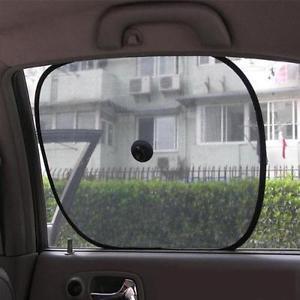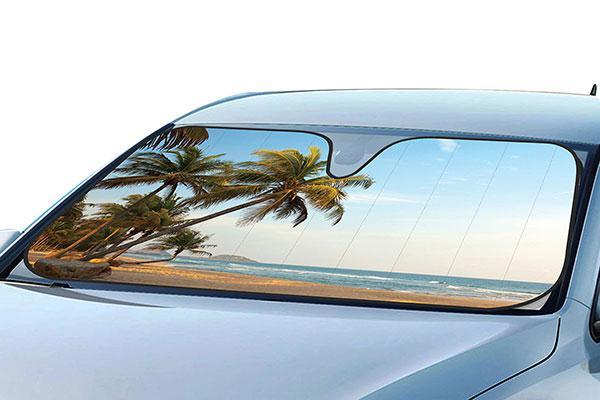The first image is the image on the left, the second image is the image on the right. Evaluate the accuracy of this statement regarding the images: "The door of the car is open.". Is it true? Answer yes or no. No. 